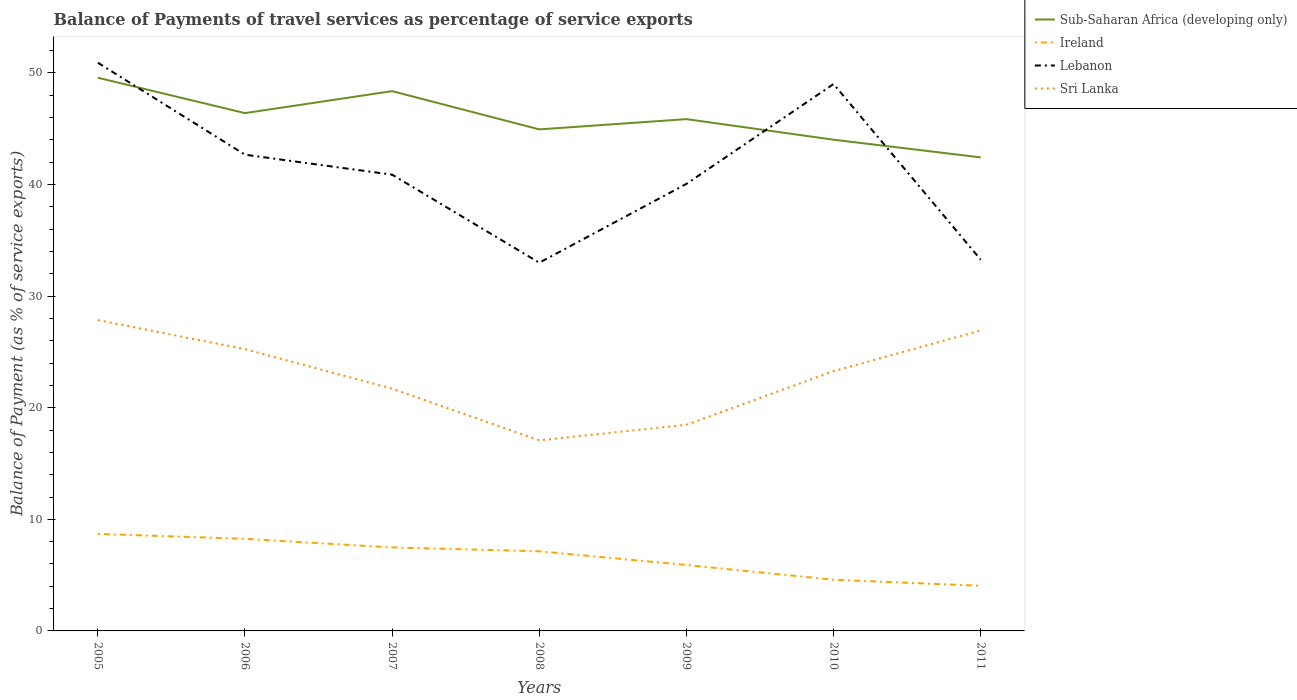Does the line corresponding to Sri Lanka intersect with the line corresponding to Sub-Saharan Africa (developing only)?
Offer a terse response. No. Across all years, what is the maximum balance of payments of travel services in Sub-Saharan Africa (developing only)?
Give a very brief answer. 42.43. In which year was the balance of payments of travel services in Sri Lanka maximum?
Ensure brevity in your answer.  2008. What is the total balance of payments of travel services in Lebanon in the graph?
Keep it short and to the point. 10.03. What is the difference between the highest and the second highest balance of payments of travel services in Ireland?
Offer a very short reply. 4.65. How many lines are there?
Give a very brief answer. 4. How many years are there in the graph?
Keep it short and to the point. 7. Are the values on the major ticks of Y-axis written in scientific E-notation?
Provide a short and direct response. No. Does the graph contain any zero values?
Provide a succinct answer. No. Does the graph contain grids?
Ensure brevity in your answer.  No. Where does the legend appear in the graph?
Give a very brief answer. Top right. How many legend labels are there?
Your response must be concise. 4. What is the title of the graph?
Your answer should be very brief. Balance of Payments of travel services as percentage of service exports. Does "Malta" appear as one of the legend labels in the graph?
Provide a short and direct response. No. What is the label or title of the Y-axis?
Provide a succinct answer. Balance of Payment (as % of service exports). What is the Balance of Payment (as % of service exports) of Sub-Saharan Africa (developing only) in 2005?
Provide a succinct answer. 49.57. What is the Balance of Payment (as % of service exports) in Ireland in 2005?
Your answer should be compact. 8.7. What is the Balance of Payment (as % of service exports) in Lebanon in 2005?
Your answer should be compact. 50.92. What is the Balance of Payment (as % of service exports) in Sri Lanka in 2005?
Your answer should be compact. 27.86. What is the Balance of Payment (as % of service exports) of Sub-Saharan Africa (developing only) in 2006?
Offer a terse response. 46.4. What is the Balance of Payment (as % of service exports) in Ireland in 2006?
Provide a short and direct response. 8.25. What is the Balance of Payment (as % of service exports) of Lebanon in 2006?
Make the answer very short. 42.68. What is the Balance of Payment (as % of service exports) of Sri Lanka in 2006?
Provide a succinct answer. 25.25. What is the Balance of Payment (as % of service exports) in Sub-Saharan Africa (developing only) in 2007?
Give a very brief answer. 48.37. What is the Balance of Payment (as % of service exports) in Ireland in 2007?
Your answer should be very brief. 7.48. What is the Balance of Payment (as % of service exports) of Lebanon in 2007?
Your answer should be very brief. 40.89. What is the Balance of Payment (as % of service exports) in Sri Lanka in 2007?
Ensure brevity in your answer.  21.71. What is the Balance of Payment (as % of service exports) in Sub-Saharan Africa (developing only) in 2008?
Ensure brevity in your answer.  44.94. What is the Balance of Payment (as % of service exports) of Ireland in 2008?
Ensure brevity in your answer.  7.14. What is the Balance of Payment (as % of service exports) of Lebanon in 2008?
Offer a very short reply. 33. What is the Balance of Payment (as % of service exports) of Sri Lanka in 2008?
Provide a short and direct response. 17.08. What is the Balance of Payment (as % of service exports) in Sub-Saharan Africa (developing only) in 2009?
Keep it short and to the point. 45.86. What is the Balance of Payment (as % of service exports) in Ireland in 2009?
Offer a very short reply. 5.91. What is the Balance of Payment (as % of service exports) in Lebanon in 2009?
Offer a terse response. 40.06. What is the Balance of Payment (as % of service exports) of Sri Lanka in 2009?
Offer a very short reply. 18.47. What is the Balance of Payment (as % of service exports) of Sub-Saharan Africa (developing only) in 2010?
Make the answer very short. 44.02. What is the Balance of Payment (as % of service exports) of Ireland in 2010?
Offer a terse response. 4.59. What is the Balance of Payment (as % of service exports) in Lebanon in 2010?
Your response must be concise. 49.01. What is the Balance of Payment (as % of service exports) in Sri Lanka in 2010?
Give a very brief answer. 23.28. What is the Balance of Payment (as % of service exports) in Sub-Saharan Africa (developing only) in 2011?
Make the answer very short. 42.43. What is the Balance of Payment (as % of service exports) of Ireland in 2011?
Offer a very short reply. 4.04. What is the Balance of Payment (as % of service exports) of Lebanon in 2011?
Give a very brief answer. 33.27. What is the Balance of Payment (as % of service exports) of Sri Lanka in 2011?
Offer a terse response. 26.92. Across all years, what is the maximum Balance of Payment (as % of service exports) in Sub-Saharan Africa (developing only)?
Provide a succinct answer. 49.57. Across all years, what is the maximum Balance of Payment (as % of service exports) in Ireland?
Keep it short and to the point. 8.7. Across all years, what is the maximum Balance of Payment (as % of service exports) of Lebanon?
Your answer should be compact. 50.92. Across all years, what is the maximum Balance of Payment (as % of service exports) of Sri Lanka?
Your response must be concise. 27.86. Across all years, what is the minimum Balance of Payment (as % of service exports) in Sub-Saharan Africa (developing only)?
Offer a very short reply. 42.43. Across all years, what is the minimum Balance of Payment (as % of service exports) in Ireland?
Give a very brief answer. 4.04. Across all years, what is the minimum Balance of Payment (as % of service exports) in Lebanon?
Keep it short and to the point. 33. Across all years, what is the minimum Balance of Payment (as % of service exports) in Sri Lanka?
Your response must be concise. 17.08. What is the total Balance of Payment (as % of service exports) in Sub-Saharan Africa (developing only) in the graph?
Offer a terse response. 321.6. What is the total Balance of Payment (as % of service exports) in Ireland in the graph?
Provide a succinct answer. 46.11. What is the total Balance of Payment (as % of service exports) in Lebanon in the graph?
Offer a very short reply. 289.81. What is the total Balance of Payment (as % of service exports) of Sri Lanka in the graph?
Keep it short and to the point. 160.57. What is the difference between the Balance of Payment (as % of service exports) of Sub-Saharan Africa (developing only) in 2005 and that in 2006?
Your answer should be very brief. 3.17. What is the difference between the Balance of Payment (as % of service exports) in Ireland in 2005 and that in 2006?
Offer a terse response. 0.45. What is the difference between the Balance of Payment (as % of service exports) in Lebanon in 2005 and that in 2006?
Your response must be concise. 8.24. What is the difference between the Balance of Payment (as % of service exports) of Sri Lanka in 2005 and that in 2006?
Keep it short and to the point. 2.61. What is the difference between the Balance of Payment (as % of service exports) of Sub-Saharan Africa (developing only) in 2005 and that in 2007?
Ensure brevity in your answer.  1.2. What is the difference between the Balance of Payment (as % of service exports) in Ireland in 2005 and that in 2007?
Your answer should be very brief. 1.22. What is the difference between the Balance of Payment (as % of service exports) of Lebanon in 2005 and that in 2007?
Your answer should be very brief. 10.03. What is the difference between the Balance of Payment (as % of service exports) in Sri Lanka in 2005 and that in 2007?
Give a very brief answer. 6.15. What is the difference between the Balance of Payment (as % of service exports) of Sub-Saharan Africa (developing only) in 2005 and that in 2008?
Offer a terse response. 4.63. What is the difference between the Balance of Payment (as % of service exports) in Ireland in 2005 and that in 2008?
Your answer should be compact. 1.56. What is the difference between the Balance of Payment (as % of service exports) of Lebanon in 2005 and that in 2008?
Your answer should be very brief. 17.92. What is the difference between the Balance of Payment (as % of service exports) in Sri Lanka in 2005 and that in 2008?
Provide a short and direct response. 10.78. What is the difference between the Balance of Payment (as % of service exports) in Sub-Saharan Africa (developing only) in 2005 and that in 2009?
Provide a succinct answer. 3.71. What is the difference between the Balance of Payment (as % of service exports) of Ireland in 2005 and that in 2009?
Your answer should be very brief. 2.79. What is the difference between the Balance of Payment (as % of service exports) of Lebanon in 2005 and that in 2009?
Offer a very short reply. 10.86. What is the difference between the Balance of Payment (as % of service exports) of Sri Lanka in 2005 and that in 2009?
Give a very brief answer. 9.38. What is the difference between the Balance of Payment (as % of service exports) of Sub-Saharan Africa (developing only) in 2005 and that in 2010?
Give a very brief answer. 5.55. What is the difference between the Balance of Payment (as % of service exports) of Ireland in 2005 and that in 2010?
Your response must be concise. 4.11. What is the difference between the Balance of Payment (as % of service exports) of Lebanon in 2005 and that in 2010?
Ensure brevity in your answer.  1.91. What is the difference between the Balance of Payment (as % of service exports) of Sri Lanka in 2005 and that in 2010?
Provide a short and direct response. 4.58. What is the difference between the Balance of Payment (as % of service exports) of Sub-Saharan Africa (developing only) in 2005 and that in 2011?
Offer a terse response. 7.14. What is the difference between the Balance of Payment (as % of service exports) of Ireland in 2005 and that in 2011?
Your answer should be compact. 4.65. What is the difference between the Balance of Payment (as % of service exports) of Lebanon in 2005 and that in 2011?
Keep it short and to the point. 17.65. What is the difference between the Balance of Payment (as % of service exports) of Sri Lanka in 2005 and that in 2011?
Offer a very short reply. 0.94. What is the difference between the Balance of Payment (as % of service exports) in Sub-Saharan Africa (developing only) in 2006 and that in 2007?
Offer a very short reply. -1.97. What is the difference between the Balance of Payment (as % of service exports) of Ireland in 2006 and that in 2007?
Offer a terse response. 0.77. What is the difference between the Balance of Payment (as % of service exports) in Lebanon in 2006 and that in 2007?
Your answer should be very brief. 1.79. What is the difference between the Balance of Payment (as % of service exports) in Sri Lanka in 2006 and that in 2007?
Provide a short and direct response. 3.54. What is the difference between the Balance of Payment (as % of service exports) of Sub-Saharan Africa (developing only) in 2006 and that in 2008?
Provide a succinct answer. 1.46. What is the difference between the Balance of Payment (as % of service exports) in Ireland in 2006 and that in 2008?
Offer a very short reply. 1.11. What is the difference between the Balance of Payment (as % of service exports) in Lebanon in 2006 and that in 2008?
Your answer should be very brief. 9.68. What is the difference between the Balance of Payment (as % of service exports) of Sri Lanka in 2006 and that in 2008?
Ensure brevity in your answer.  8.17. What is the difference between the Balance of Payment (as % of service exports) of Sub-Saharan Africa (developing only) in 2006 and that in 2009?
Your response must be concise. 0.54. What is the difference between the Balance of Payment (as % of service exports) in Ireland in 2006 and that in 2009?
Offer a terse response. 2.34. What is the difference between the Balance of Payment (as % of service exports) in Lebanon in 2006 and that in 2009?
Offer a terse response. 2.62. What is the difference between the Balance of Payment (as % of service exports) in Sri Lanka in 2006 and that in 2009?
Make the answer very short. 6.78. What is the difference between the Balance of Payment (as % of service exports) of Sub-Saharan Africa (developing only) in 2006 and that in 2010?
Your answer should be very brief. 2.38. What is the difference between the Balance of Payment (as % of service exports) of Ireland in 2006 and that in 2010?
Your answer should be compact. 3.67. What is the difference between the Balance of Payment (as % of service exports) in Lebanon in 2006 and that in 2010?
Your answer should be compact. -6.33. What is the difference between the Balance of Payment (as % of service exports) of Sri Lanka in 2006 and that in 2010?
Keep it short and to the point. 1.97. What is the difference between the Balance of Payment (as % of service exports) in Sub-Saharan Africa (developing only) in 2006 and that in 2011?
Offer a terse response. 3.97. What is the difference between the Balance of Payment (as % of service exports) in Ireland in 2006 and that in 2011?
Your response must be concise. 4.21. What is the difference between the Balance of Payment (as % of service exports) in Lebanon in 2006 and that in 2011?
Make the answer very short. 9.41. What is the difference between the Balance of Payment (as % of service exports) of Sri Lanka in 2006 and that in 2011?
Offer a terse response. -1.67. What is the difference between the Balance of Payment (as % of service exports) of Sub-Saharan Africa (developing only) in 2007 and that in 2008?
Offer a very short reply. 3.43. What is the difference between the Balance of Payment (as % of service exports) in Ireland in 2007 and that in 2008?
Ensure brevity in your answer.  0.35. What is the difference between the Balance of Payment (as % of service exports) in Lebanon in 2007 and that in 2008?
Ensure brevity in your answer.  7.89. What is the difference between the Balance of Payment (as % of service exports) in Sri Lanka in 2007 and that in 2008?
Keep it short and to the point. 4.63. What is the difference between the Balance of Payment (as % of service exports) of Sub-Saharan Africa (developing only) in 2007 and that in 2009?
Ensure brevity in your answer.  2.51. What is the difference between the Balance of Payment (as % of service exports) of Ireland in 2007 and that in 2009?
Ensure brevity in your answer.  1.57. What is the difference between the Balance of Payment (as % of service exports) of Lebanon in 2007 and that in 2009?
Keep it short and to the point. 0.83. What is the difference between the Balance of Payment (as % of service exports) of Sri Lanka in 2007 and that in 2009?
Your answer should be very brief. 3.23. What is the difference between the Balance of Payment (as % of service exports) in Sub-Saharan Africa (developing only) in 2007 and that in 2010?
Offer a terse response. 4.35. What is the difference between the Balance of Payment (as % of service exports) of Ireland in 2007 and that in 2010?
Your response must be concise. 2.9. What is the difference between the Balance of Payment (as % of service exports) of Lebanon in 2007 and that in 2010?
Your answer should be very brief. -8.12. What is the difference between the Balance of Payment (as % of service exports) of Sri Lanka in 2007 and that in 2010?
Your answer should be compact. -1.57. What is the difference between the Balance of Payment (as % of service exports) of Sub-Saharan Africa (developing only) in 2007 and that in 2011?
Provide a short and direct response. 5.94. What is the difference between the Balance of Payment (as % of service exports) in Ireland in 2007 and that in 2011?
Your answer should be very brief. 3.44. What is the difference between the Balance of Payment (as % of service exports) of Lebanon in 2007 and that in 2011?
Keep it short and to the point. 7.62. What is the difference between the Balance of Payment (as % of service exports) of Sri Lanka in 2007 and that in 2011?
Provide a succinct answer. -5.22. What is the difference between the Balance of Payment (as % of service exports) in Sub-Saharan Africa (developing only) in 2008 and that in 2009?
Offer a terse response. -0.92. What is the difference between the Balance of Payment (as % of service exports) of Ireland in 2008 and that in 2009?
Give a very brief answer. 1.23. What is the difference between the Balance of Payment (as % of service exports) of Lebanon in 2008 and that in 2009?
Make the answer very short. -7.06. What is the difference between the Balance of Payment (as % of service exports) in Sri Lanka in 2008 and that in 2009?
Your answer should be compact. -1.39. What is the difference between the Balance of Payment (as % of service exports) of Sub-Saharan Africa (developing only) in 2008 and that in 2010?
Ensure brevity in your answer.  0.92. What is the difference between the Balance of Payment (as % of service exports) in Ireland in 2008 and that in 2010?
Your answer should be compact. 2.55. What is the difference between the Balance of Payment (as % of service exports) of Lebanon in 2008 and that in 2010?
Provide a succinct answer. -16.01. What is the difference between the Balance of Payment (as % of service exports) of Sri Lanka in 2008 and that in 2010?
Offer a terse response. -6.2. What is the difference between the Balance of Payment (as % of service exports) in Sub-Saharan Africa (developing only) in 2008 and that in 2011?
Your response must be concise. 2.51. What is the difference between the Balance of Payment (as % of service exports) of Ireland in 2008 and that in 2011?
Keep it short and to the point. 3.09. What is the difference between the Balance of Payment (as % of service exports) in Lebanon in 2008 and that in 2011?
Keep it short and to the point. -0.27. What is the difference between the Balance of Payment (as % of service exports) in Sri Lanka in 2008 and that in 2011?
Keep it short and to the point. -9.84. What is the difference between the Balance of Payment (as % of service exports) of Sub-Saharan Africa (developing only) in 2009 and that in 2010?
Your answer should be very brief. 1.84. What is the difference between the Balance of Payment (as % of service exports) in Ireland in 2009 and that in 2010?
Give a very brief answer. 1.32. What is the difference between the Balance of Payment (as % of service exports) of Lebanon in 2009 and that in 2010?
Give a very brief answer. -8.95. What is the difference between the Balance of Payment (as % of service exports) in Sri Lanka in 2009 and that in 2010?
Provide a succinct answer. -4.8. What is the difference between the Balance of Payment (as % of service exports) of Sub-Saharan Africa (developing only) in 2009 and that in 2011?
Provide a short and direct response. 3.43. What is the difference between the Balance of Payment (as % of service exports) in Ireland in 2009 and that in 2011?
Offer a terse response. 1.86. What is the difference between the Balance of Payment (as % of service exports) of Lebanon in 2009 and that in 2011?
Your answer should be compact. 6.79. What is the difference between the Balance of Payment (as % of service exports) of Sri Lanka in 2009 and that in 2011?
Your response must be concise. -8.45. What is the difference between the Balance of Payment (as % of service exports) in Sub-Saharan Africa (developing only) in 2010 and that in 2011?
Provide a short and direct response. 1.59. What is the difference between the Balance of Payment (as % of service exports) of Ireland in 2010 and that in 2011?
Provide a succinct answer. 0.54. What is the difference between the Balance of Payment (as % of service exports) in Lebanon in 2010 and that in 2011?
Provide a short and direct response. 15.74. What is the difference between the Balance of Payment (as % of service exports) of Sri Lanka in 2010 and that in 2011?
Provide a succinct answer. -3.65. What is the difference between the Balance of Payment (as % of service exports) in Sub-Saharan Africa (developing only) in 2005 and the Balance of Payment (as % of service exports) in Ireland in 2006?
Your answer should be very brief. 41.32. What is the difference between the Balance of Payment (as % of service exports) in Sub-Saharan Africa (developing only) in 2005 and the Balance of Payment (as % of service exports) in Lebanon in 2006?
Make the answer very short. 6.9. What is the difference between the Balance of Payment (as % of service exports) in Sub-Saharan Africa (developing only) in 2005 and the Balance of Payment (as % of service exports) in Sri Lanka in 2006?
Provide a succinct answer. 24.32. What is the difference between the Balance of Payment (as % of service exports) of Ireland in 2005 and the Balance of Payment (as % of service exports) of Lebanon in 2006?
Provide a short and direct response. -33.98. What is the difference between the Balance of Payment (as % of service exports) in Ireland in 2005 and the Balance of Payment (as % of service exports) in Sri Lanka in 2006?
Offer a very short reply. -16.55. What is the difference between the Balance of Payment (as % of service exports) of Lebanon in 2005 and the Balance of Payment (as % of service exports) of Sri Lanka in 2006?
Offer a very short reply. 25.67. What is the difference between the Balance of Payment (as % of service exports) in Sub-Saharan Africa (developing only) in 2005 and the Balance of Payment (as % of service exports) in Ireland in 2007?
Give a very brief answer. 42.09. What is the difference between the Balance of Payment (as % of service exports) in Sub-Saharan Africa (developing only) in 2005 and the Balance of Payment (as % of service exports) in Lebanon in 2007?
Offer a very short reply. 8.69. What is the difference between the Balance of Payment (as % of service exports) in Sub-Saharan Africa (developing only) in 2005 and the Balance of Payment (as % of service exports) in Sri Lanka in 2007?
Provide a short and direct response. 27.86. What is the difference between the Balance of Payment (as % of service exports) in Ireland in 2005 and the Balance of Payment (as % of service exports) in Lebanon in 2007?
Keep it short and to the point. -32.19. What is the difference between the Balance of Payment (as % of service exports) in Ireland in 2005 and the Balance of Payment (as % of service exports) in Sri Lanka in 2007?
Offer a terse response. -13.01. What is the difference between the Balance of Payment (as % of service exports) of Lebanon in 2005 and the Balance of Payment (as % of service exports) of Sri Lanka in 2007?
Provide a succinct answer. 29.21. What is the difference between the Balance of Payment (as % of service exports) of Sub-Saharan Africa (developing only) in 2005 and the Balance of Payment (as % of service exports) of Ireland in 2008?
Give a very brief answer. 42.43. What is the difference between the Balance of Payment (as % of service exports) in Sub-Saharan Africa (developing only) in 2005 and the Balance of Payment (as % of service exports) in Lebanon in 2008?
Your response must be concise. 16.58. What is the difference between the Balance of Payment (as % of service exports) in Sub-Saharan Africa (developing only) in 2005 and the Balance of Payment (as % of service exports) in Sri Lanka in 2008?
Provide a succinct answer. 32.49. What is the difference between the Balance of Payment (as % of service exports) in Ireland in 2005 and the Balance of Payment (as % of service exports) in Lebanon in 2008?
Make the answer very short. -24.3. What is the difference between the Balance of Payment (as % of service exports) in Ireland in 2005 and the Balance of Payment (as % of service exports) in Sri Lanka in 2008?
Give a very brief answer. -8.38. What is the difference between the Balance of Payment (as % of service exports) in Lebanon in 2005 and the Balance of Payment (as % of service exports) in Sri Lanka in 2008?
Your response must be concise. 33.84. What is the difference between the Balance of Payment (as % of service exports) in Sub-Saharan Africa (developing only) in 2005 and the Balance of Payment (as % of service exports) in Ireland in 2009?
Make the answer very short. 43.66. What is the difference between the Balance of Payment (as % of service exports) of Sub-Saharan Africa (developing only) in 2005 and the Balance of Payment (as % of service exports) of Lebanon in 2009?
Your response must be concise. 9.51. What is the difference between the Balance of Payment (as % of service exports) in Sub-Saharan Africa (developing only) in 2005 and the Balance of Payment (as % of service exports) in Sri Lanka in 2009?
Keep it short and to the point. 31.1. What is the difference between the Balance of Payment (as % of service exports) in Ireland in 2005 and the Balance of Payment (as % of service exports) in Lebanon in 2009?
Keep it short and to the point. -31.36. What is the difference between the Balance of Payment (as % of service exports) in Ireland in 2005 and the Balance of Payment (as % of service exports) in Sri Lanka in 2009?
Offer a very short reply. -9.78. What is the difference between the Balance of Payment (as % of service exports) of Lebanon in 2005 and the Balance of Payment (as % of service exports) of Sri Lanka in 2009?
Give a very brief answer. 32.44. What is the difference between the Balance of Payment (as % of service exports) of Sub-Saharan Africa (developing only) in 2005 and the Balance of Payment (as % of service exports) of Ireland in 2010?
Your answer should be compact. 44.99. What is the difference between the Balance of Payment (as % of service exports) of Sub-Saharan Africa (developing only) in 2005 and the Balance of Payment (as % of service exports) of Lebanon in 2010?
Ensure brevity in your answer.  0.57. What is the difference between the Balance of Payment (as % of service exports) in Sub-Saharan Africa (developing only) in 2005 and the Balance of Payment (as % of service exports) in Sri Lanka in 2010?
Your answer should be compact. 26.29. What is the difference between the Balance of Payment (as % of service exports) of Ireland in 2005 and the Balance of Payment (as % of service exports) of Lebanon in 2010?
Your response must be concise. -40.31. What is the difference between the Balance of Payment (as % of service exports) of Ireland in 2005 and the Balance of Payment (as % of service exports) of Sri Lanka in 2010?
Offer a very short reply. -14.58. What is the difference between the Balance of Payment (as % of service exports) in Lebanon in 2005 and the Balance of Payment (as % of service exports) in Sri Lanka in 2010?
Your answer should be very brief. 27.64. What is the difference between the Balance of Payment (as % of service exports) in Sub-Saharan Africa (developing only) in 2005 and the Balance of Payment (as % of service exports) in Ireland in 2011?
Make the answer very short. 45.53. What is the difference between the Balance of Payment (as % of service exports) in Sub-Saharan Africa (developing only) in 2005 and the Balance of Payment (as % of service exports) in Lebanon in 2011?
Offer a terse response. 16.3. What is the difference between the Balance of Payment (as % of service exports) of Sub-Saharan Africa (developing only) in 2005 and the Balance of Payment (as % of service exports) of Sri Lanka in 2011?
Give a very brief answer. 22.65. What is the difference between the Balance of Payment (as % of service exports) in Ireland in 2005 and the Balance of Payment (as % of service exports) in Lebanon in 2011?
Your answer should be very brief. -24.57. What is the difference between the Balance of Payment (as % of service exports) in Ireland in 2005 and the Balance of Payment (as % of service exports) in Sri Lanka in 2011?
Provide a short and direct response. -18.23. What is the difference between the Balance of Payment (as % of service exports) of Lebanon in 2005 and the Balance of Payment (as % of service exports) of Sri Lanka in 2011?
Your answer should be compact. 23.99. What is the difference between the Balance of Payment (as % of service exports) in Sub-Saharan Africa (developing only) in 2006 and the Balance of Payment (as % of service exports) in Ireland in 2007?
Keep it short and to the point. 38.92. What is the difference between the Balance of Payment (as % of service exports) of Sub-Saharan Africa (developing only) in 2006 and the Balance of Payment (as % of service exports) of Lebanon in 2007?
Make the answer very short. 5.52. What is the difference between the Balance of Payment (as % of service exports) of Sub-Saharan Africa (developing only) in 2006 and the Balance of Payment (as % of service exports) of Sri Lanka in 2007?
Your answer should be very brief. 24.7. What is the difference between the Balance of Payment (as % of service exports) of Ireland in 2006 and the Balance of Payment (as % of service exports) of Lebanon in 2007?
Give a very brief answer. -32.63. What is the difference between the Balance of Payment (as % of service exports) in Ireland in 2006 and the Balance of Payment (as % of service exports) in Sri Lanka in 2007?
Ensure brevity in your answer.  -13.46. What is the difference between the Balance of Payment (as % of service exports) in Lebanon in 2006 and the Balance of Payment (as % of service exports) in Sri Lanka in 2007?
Provide a succinct answer. 20.97. What is the difference between the Balance of Payment (as % of service exports) of Sub-Saharan Africa (developing only) in 2006 and the Balance of Payment (as % of service exports) of Ireland in 2008?
Ensure brevity in your answer.  39.27. What is the difference between the Balance of Payment (as % of service exports) of Sub-Saharan Africa (developing only) in 2006 and the Balance of Payment (as % of service exports) of Lebanon in 2008?
Your answer should be compact. 13.41. What is the difference between the Balance of Payment (as % of service exports) in Sub-Saharan Africa (developing only) in 2006 and the Balance of Payment (as % of service exports) in Sri Lanka in 2008?
Provide a succinct answer. 29.32. What is the difference between the Balance of Payment (as % of service exports) in Ireland in 2006 and the Balance of Payment (as % of service exports) in Lebanon in 2008?
Ensure brevity in your answer.  -24.74. What is the difference between the Balance of Payment (as % of service exports) of Ireland in 2006 and the Balance of Payment (as % of service exports) of Sri Lanka in 2008?
Your response must be concise. -8.83. What is the difference between the Balance of Payment (as % of service exports) in Lebanon in 2006 and the Balance of Payment (as % of service exports) in Sri Lanka in 2008?
Your answer should be very brief. 25.6. What is the difference between the Balance of Payment (as % of service exports) in Sub-Saharan Africa (developing only) in 2006 and the Balance of Payment (as % of service exports) in Ireland in 2009?
Your response must be concise. 40.49. What is the difference between the Balance of Payment (as % of service exports) in Sub-Saharan Africa (developing only) in 2006 and the Balance of Payment (as % of service exports) in Lebanon in 2009?
Keep it short and to the point. 6.34. What is the difference between the Balance of Payment (as % of service exports) of Sub-Saharan Africa (developing only) in 2006 and the Balance of Payment (as % of service exports) of Sri Lanka in 2009?
Offer a very short reply. 27.93. What is the difference between the Balance of Payment (as % of service exports) of Ireland in 2006 and the Balance of Payment (as % of service exports) of Lebanon in 2009?
Offer a very short reply. -31.81. What is the difference between the Balance of Payment (as % of service exports) of Ireland in 2006 and the Balance of Payment (as % of service exports) of Sri Lanka in 2009?
Provide a short and direct response. -10.22. What is the difference between the Balance of Payment (as % of service exports) in Lebanon in 2006 and the Balance of Payment (as % of service exports) in Sri Lanka in 2009?
Your response must be concise. 24.2. What is the difference between the Balance of Payment (as % of service exports) in Sub-Saharan Africa (developing only) in 2006 and the Balance of Payment (as % of service exports) in Ireland in 2010?
Provide a succinct answer. 41.82. What is the difference between the Balance of Payment (as % of service exports) of Sub-Saharan Africa (developing only) in 2006 and the Balance of Payment (as % of service exports) of Lebanon in 2010?
Offer a terse response. -2.6. What is the difference between the Balance of Payment (as % of service exports) of Sub-Saharan Africa (developing only) in 2006 and the Balance of Payment (as % of service exports) of Sri Lanka in 2010?
Make the answer very short. 23.12. What is the difference between the Balance of Payment (as % of service exports) of Ireland in 2006 and the Balance of Payment (as % of service exports) of Lebanon in 2010?
Keep it short and to the point. -40.76. What is the difference between the Balance of Payment (as % of service exports) of Ireland in 2006 and the Balance of Payment (as % of service exports) of Sri Lanka in 2010?
Give a very brief answer. -15.03. What is the difference between the Balance of Payment (as % of service exports) of Lebanon in 2006 and the Balance of Payment (as % of service exports) of Sri Lanka in 2010?
Keep it short and to the point. 19.4. What is the difference between the Balance of Payment (as % of service exports) in Sub-Saharan Africa (developing only) in 2006 and the Balance of Payment (as % of service exports) in Ireland in 2011?
Provide a succinct answer. 42.36. What is the difference between the Balance of Payment (as % of service exports) in Sub-Saharan Africa (developing only) in 2006 and the Balance of Payment (as % of service exports) in Lebanon in 2011?
Provide a succinct answer. 13.13. What is the difference between the Balance of Payment (as % of service exports) of Sub-Saharan Africa (developing only) in 2006 and the Balance of Payment (as % of service exports) of Sri Lanka in 2011?
Provide a short and direct response. 19.48. What is the difference between the Balance of Payment (as % of service exports) of Ireland in 2006 and the Balance of Payment (as % of service exports) of Lebanon in 2011?
Your response must be concise. -25.02. What is the difference between the Balance of Payment (as % of service exports) in Ireland in 2006 and the Balance of Payment (as % of service exports) in Sri Lanka in 2011?
Ensure brevity in your answer.  -18.67. What is the difference between the Balance of Payment (as % of service exports) in Lebanon in 2006 and the Balance of Payment (as % of service exports) in Sri Lanka in 2011?
Give a very brief answer. 15.75. What is the difference between the Balance of Payment (as % of service exports) in Sub-Saharan Africa (developing only) in 2007 and the Balance of Payment (as % of service exports) in Ireland in 2008?
Ensure brevity in your answer.  41.23. What is the difference between the Balance of Payment (as % of service exports) of Sub-Saharan Africa (developing only) in 2007 and the Balance of Payment (as % of service exports) of Lebanon in 2008?
Offer a terse response. 15.38. What is the difference between the Balance of Payment (as % of service exports) in Sub-Saharan Africa (developing only) in 2007 and the Balance of Payment (as % of service exports) in Sri Lanka in 2008?
Offer a very short reply. 31.29. What is the difference between the Balance of Payment (as % of service exports) in Ireland in 2007 and the Balance of Payment (as % of service exports) in Lebanon in 2008?
Make the answer very short. -25.51. What is the difference between the Balance of Payment (as % of service exports) of Ireland in 2007 and the Balance of Payment (as % of service exports) of Sri Lanka in 2008?
Offer a very short reply. -9.6. What is the difference between the Balance of Payment (as % of service exports) of Lebanon in 2007 and the Balance of Payment (as % of service exports) of Sri Lanka in 2008?
Your answer should be compact. 23.81. What is the difference between the Balance of Payment (as % of service exports) of Sub-Saharan Africa (developing only) in 2007 and the Balance of Payment (as % of service exports) of Ireland in 2009?
Offer a very short reply. 42.46. What is the difference between the Balance of Payment (as % of service exports) of Sub-Saharan Africa (developing only) in 2007 and the Balance of Payment (as % of service exports) of Lebanon in 2009?
Your answer should be very brief. 8.31. What is the difference between the Balance of Payment (as % of service exports) in Sub-Saharan Africa (developing only) in 2007 and the Balance of Payment (as % of service exports) in Sri Lanka in 2009?
Provide a short and direct response. 29.9. What is the difference between the Balance of Payment (as % of service exports) in Ireland in 2007 and the Balance of Payment (as % of service exports) in Lebanon in 2009?
Your answer should be compact. -32.58. What is the difference between the Balance of Payment (as % of service exports) in Ireland in 2007 and the Balance of Payment (as % of service exports) in Sri Lanka in 2009?
Give a very brief answer. -10.99. What is the difference between the Balance of Payment (as % of service exports) in Lebanon in 2007 and the Balance of Payment (as % of service exports) in Sri Lanka in 2009?
Keep it short and to the point. 22.41. What is the difference between the Balance of Payment (as % of service exports) in Sub-Saharan Africa (developing only) in 2007 and the Balance of Payment (as % of service exports) in Ireland in 2010?
Provide a short and direct response. 43.79. What is the difference between the Balance of Payment (as % of service exports) of Sub-Saharan Africa (developing only) in 2007 and the Balance of Payment (as % of service exports) of Lebanon in 2010?
Offer a terse response. -0.64. What is the difference between the Balance of Payment (as % of service exports) in Sub-Saharan Africa (developing only) in 2007 and the Balance of Payment (as % of service exports) in Sri Lanka in 2010?
Ensure brevity in your answer.  25.09. What is the difference between the Balance of Payment (as % of service exports) of Ireland in 2007 and the Balance of Payment (as % of service exports) of Lebanon in 2010?
Your answer should be compact. -41.52. What is the difference between the Balance of Payment (as % of service exports) in Ireland in 2007 and the Balance of Payment (as % of service exports) in Sri Lanka in 2010?
Provide a short and direct response. -15.8. What is the difference between the Balance of Payment (as % of service exports) of Lebanon in 2007 and the Balance of Payment (as % of service exports) of Sri Lanka in 2010?
Give a very brief answer. 17.61. What is the difference between the Balance of Payment (as % of service exports) of Sub-Saharan Africa (developing only) in 2007 and the Balance of Payment (as % of service exports) of Ireland in 2011?
Your answer should be compact. 44.33. What is the difference between the Balance of Payment (as % of service exports) in Sub-Saharan Africa (developing only) in 2007 and the Balance of Payment (as % of service exports) in Lebanon in 2011?
Your answer should be very brief. 15.1. What is the difference between the Balance of Payment (as % of service exports) of Sub-Saharan Africa (developing only) in 2007 and the Balance of Payment (as % of service exports) of Sri Lanka in 2011?
Offer a very short reply. 21.45. What is the difference between the Balance of Payment (as % of service exports) of Ireland in 2007 and the Balance of Payment (as % of service exports) of Lebanon in 2011?
Ensure brevity in your answer.  -25.79. What is the difference between the Balance of Payment (as % of service exports) of Ireland in 2007 and the Balance of Payment (as % of service exports) of Sri Lanka in 2011?
Make the answer very short. -19.44. What is the difference between the Balance of Payment (as % of service exports) in Lebanon in 2007 and the Balance of Payment (as % of service exports) in Sri Lanka in 2011?
Your answer should be compact. 13.96. What is the difference between the Balance of Payment (as % of service exports) in Sub-Saharan Africa (developing only) in 2008 and the Balance of Payment (as % of service exports) in Ireland in 2009?
Your answer should be very brief. 39.04. What is the difference between the Balance of Payment (as % of service exports) in Sub-Saharan Africa (developing only) in 2008 and the Balance of Payment (as % of service exports) in Lebanon in 2009?
Make the answer very short. 4.88. What is the difference between the Balance of Payment (as % of service exports) of Sub-Saharan Africa (developing only) in 2008 and the Balance of Payment (as % of service exports) of Sri Lanka in 2009?
Provide a short and direct response. 26.47. What is the difference between the Balance of Payment (as % of service exports) of Ireland in 2008 and the Balance of Payment (as % of service exports) of Lebanon in 2009?
Your answer should be very brief. -32.92. What is the difference between the Balance of Payment (as % of service exports) in Ireland in 2008 and the Balance of Payment (as % of service exports) in Sri Lanka in 2009?
Offer a terse response. -11.34. What is the difference between the Balance of Payment (as % of service exports) in Lebanon in 2008 and the Balance of Payment (as % of service exports) in Sri Lanka in 2009?
Make the answer very short. 14.52. What is the difference between the Balance of Payment (as % of service exports) in Sub-Saharan Africa (developing only) in 2008 and the Balance of Payment (as % of service exports) in Ireland in 2010?
Provide a short and direct response. 40.36. What is the difference between the Balance of Payment (as % of service exports) in Sub-Saharan Africa (developing only) in 2008 and the Balance of Payment (as % of service exports) in Lebanon in 2010?
Offer a very short reply. -4.06. What is the difference between the Balance of Payment (as % of service exports) of Sub-Saharan Africa (developing only) in 2008 and the Balance of Payment (as % of service exports) of Sri Lanka in 2010?
Make the answer very short. 21.67. What is the difference between the Balance of Payment (as % of service exports) in Ireland in 2008 and the Balance of Payment (as % of service exports) in Lebanon in 2010?
Ensure brevity in your answer.  -41.87. What is the difference between the Balance of Payment (as % of service exports) in Ireland in 2008 and the Balance of Payment (as % of service exports) in Sri Lanka in 2010?
Offer a very short reply. -16.14. What is the difference between the Balance of Payment (as % of service exports) in Lebanon in 2008 and the Balance of Payment (as % of service exports) in Sri Lanka in 2010?
Your answer should be very brief. 9.72. What is the difference between the Balance of Payment (as % of service exports) of Sub-Saharan Africa (developing only) in 2008 and the Balance of Payment (as % of service exports) of Ireland in 2011?
Give a very brief answer. 40.9. What is the difference between the Balance of Payment (as % of service exports) in Sub-Saharan Africa (developing only) in 2008 and the Balance of Payment (as % of service exports) in Lebanon in 2011?
Offer a terse response. 11.68. What is the difference between the Balance of Payment (as % of service exports) of Sub-Saharan Africa (developing only) in 2008 and the Balance of Payment (as % of service exports) of Sri Lanka in 2011?
Keep it short and to the point. 18.02. What is the difference between the Balance of Payment (as % of service exports) of Ireland in 2008 and the Balance of Payment (as % of service exports) of Lebanon in 2011?
Keep it short and to the point. -26.13. What is the difference between the Balance of Payment (as % of service exports) in Ireland in 2008 and the Balance of Payment (as % of service exports) in Sri Lanka in 2011?
Your response must be concise. -19.79. What is the difference between the Balance of Payment (as % of service exports) in Lebanon in 2008 and the Balance of Payment (as % of service exports) in Sri Lanka in 2011?
Keep it short and to the point. 6.07. What is the difference between the Balance of Payment (as % of service exports) of Sub-Saharan Africa (developing only) in 2009 and the Balance of Payment (as % of service exports) of Ireland in 2010?
Make the answer very short. 41.28. What is the difference between the Balance of Payment (as % of service exports) in Sub-Saharan Africa (developing only) in 2009 and the Balance of Payment (as % of service exports) in Lebanon in 2010?
Offer a very short reply. -3.14. What is the difference between the Balance of Payment (as % of service exports) in Sub-Saharan Africa (developing only) in 2009 and the Balance of Payment (as % of service exports) in Sri Lanka in 2010?
Make the answer very short. 22.58. What is the difference between the Balance of Payment (as % of service exports) of Ireland in 2009 and the Balance of Payment (as % of service exports) of Lebanon in 2010?
Ensure brevity in your answer.  -43.1. What is the difference between the Balance of Payment (as % of service exports) in Ireland in 2009 and the Balance of Payment (as % of service exports) in Sri Lanka in 2010?
Keep it short and to the point. -17.37. What is the difference between the Balance of Payment (as % of service exports) in Lebanon in 2009 and the Balance of Payment (as % of service exports) in Sri Lanka in 2010?
Your answer should be very brief. 16.78. What is the difference between the Balance of Payment (as % of service exports) in Sub-Saharan Africa (developing only) in 2009 and the Balance of Payment (as % of service exports) in Ireland in 2011?
Provide a succinct answer. 41.82. What is the difference between the Balance of Payment (as % of service exports) of Sub-Saharan Africa (developing only) in 2009 and the Balance of Payment (as % of service exports) of Lebanon in 2011?
Your answer should be compact. 12.59. What is the difference between the Balance of Payment (as % of service exports) in Sub-Saharan Africa (developing only) in 2009 and the Balance of Payment (as % of service exports) in Sri Lanka in 2011?
Provide a short and direct response. 18.94. What is the difference between the Balance of Payment (as % of service exports) in Ireland in 2009 and the Balance of Payment (as % of service exports) in Lebanon in 2011?
Keep it short and to the point. -27.36. What is the difference between the Balance of Payment (as % of service exports) in Ireland in 2009 and the Balance of Payment (as % of service exports) in Sri Lanka in 2011?
Your answer should be very brief. -21.02. What is the difference between the Balance of Payment (as % of service exports) in Lebanon in 2009 and the Balance of Payment (as % of service exports) in Sri Lanka in 2011?
Ensure brevity in your answer.  13.14. What is the difference between the Balance of Payment (as % of service exports) of Sub-Saharan Africa (developing only) in 2010 and the Balance of Payment (as % of service exports) of Ireland in 2011?
Give a very brief answer. 39.97. What is the difference between the Balance of Payment (as % of service exports) in Sub-Saharan Africa (developing only) in 2010 and the Balance of Payment (as % of service exports) in Lebanon in 2011?
Provide a succinct answer. 10.75. What is the difference between the Balance of Payment (as % of service exports) in Sub-Saharan Africa (developing only) in 2010 and the Balance of Payment (as % of service exports) in Sri Lanka in 2011?
Offer a terse response. 17.1. What is the difference between the Balance of Payment (as % of service exports) in Ireland in 2010 and the Balance of Payment (as % of service exports) in Lebanon in 2011?
Offer a very short reply. -28.68. What is the difference between the Balance of Payment (as % of service exports) in Ireland in 2010 and the Balance of Payment (as % of service exports) in Sri Lanka in 2011?
Keep it short and to the point. -22.34. What is the difference between the Balance of Payment (as % of service exports) of Lebanon in 2010 and the Balance of Payment (as % of service exports) of Sri Lanka in 2011?
Provide a short and direct response. 22.08. What is the average Balance of Payment (as % of service exports) in Sub-Saharan Africa (developing only) per year?
Offer a very short reply. 45.94. What is the average Balance of Payment (as % of service exports) in Ireland per year?
Provide a short and direct response. 6.59. What is the average Balance of Payment (as % of service exports) in Lebanon per year?
Offer a terse response. 41.4. What is the average Balance of Payment (as % of service exports) of Sri Lanka per year?
Keep it short and to the point. 22.94. In the year 2005, what is the difference between the Balance of Payment (as % of service exports) in Sub-Saharan Africa (developing only) and Balance of Payment (as % of service exports) in Ireland?
Your response must be concise. 40.87. In the year 2005, what is the difference between the Balance of Payment (as % of service exports) in Sub-Saharan Africa (developing only) and Balance of Payment (as % of service exports) in Lebanon?
Offer a very short reply. -1.35. In the year 2005, what is the difference between the Balance of Payment (as % of service exports) in Sub-Saharan Africa (developing only) and Balance of Payment (as % of service exports) in Sri Lanka?
Make the answer very short. 21.71. In the year 2005, what is the difference between the Balance of Payment (as % of service exports) in Ireland and Balance of Payment (as % of service exports) in Lebanon?
Offer a very short reply. -42.22. In the year 2005, what is the difference between the Balance of Payment (as % of service exports) in Ireland and Balance of Payment (as % of service exports) in Sri Lanka?
Your answer should be compact. -19.16. In the year 2005, what is the difference between the Balance of Payment (as % of service exports) in Lebanon and Balance of Payment (as % of service exports) in Sri Lanka?
Keep it short and to the point. 23.06. In the year 2006, what is the difference between the Balance of Payment (as % of service exports) of Sub-Saharan Africa (developing only) and Balance of Payment (as % of service exports) of Ireland?
Make the answer very short. 38.15. In the year 2006, what is the difference between the Balance of Payment (as % of service exports) in Sub-Saharan Africa (developing only) and Balance of Payment (as % of service exports) in Lebanon?
Ensure brevity in your answer.  3.73. In the year 2006, what is the difference between the Balance of Payment (as % of service exports) in Sub-Saharan Africa (developing only) and Balance of Payment (as % of service exports) in Sri Lanka?
Offer a terse response. 21.15. In the year 2006, what is the difference between the Balance of Payment (as % of service exports) in Ireland and Balance of Payment (as % of service exports) in Lebanon?
Your answer should be very brief. -34.42. In the year 2006, what is the difference between the Balance of Payment (as % of service exports) of Ireland and Balance of Payment (as % of service exports) of Sri Lanka?
Give a very brief answer. -17. In the year 2006, what is the difference between the Balance of Payment (as % of service exports) in Lebanon and Balance of Payment (as % of service exports) in Sri Lanka?
Ensure brevity in your answer.  17.42. In the year 2007, what is the difference between the Balance of Payment (as % of service exports) in Sub-Saharan Africa (developing only) and Balance of Payment (as % of service exports) in Ireland?
Offer a very short reply. 40.89. In the year 2007, what is the difference between the Balance of Payment (as % of service exports) of Sub-Saharan Africa (developing only) and Balance of Payment (as % of service exports) of Lebanon?
Your answer should be compact. 7.49. In the year 2007, what is the difference between the Balance of Payment (as % of service exports) in Sub-Saharan Africa (developing only) and Balance of Payment (as % of service exports) in Sri Lanka?
Offer a very short reply. 26.66. In the year 2007, what is the difference between the Balance of Payment (as % of service exports) of Ireland and Balance of Payment (as % of service exports) of Lebanon?
Keep it short and to the point. -33.4. In the year 2007, what is the difference between the Balance of Payment (as % of service exports) in Ireland and Balance of Payment (as % of service exports) in Sri Lanka?
Your answer should be compact. -14.22. In the year 2007, what is the difference between the Balance of Payment (as % of service exports) in Lebanon and Balance of Payment (as % of service exports) in Sri Lanka?
Offer a very short reply. 19.18. In the year 2008, what is the difference between the Balance of Payment (as % of service exports) of Sub-Saharan Africa (developing only) and Balance of Payment (as % of service exports) of Ireland?
Offer a terse response. 37.81. In the year 2008, what is the difference between the Balance of Payment (as % of service exports) of Sub-Saharan Africa (developing only) and Balance of Payment (as % of service exports) of Lebanon?
Keep it short and to the point. 11.95. In the year 2008, what is the difference between the Balance of Payment (as % of service exports) in Sub-Saharan Africa (developing only) and Balance of Payment (as % of service exports) in Sri Lanka?
Make the answer very short. 27.86. In the year 2008, what is the difference between the Balance of Payment (as % of service exports) in Ireland and Balance of Payment (as % of service exports) in Lebanon?
Give a very brief answer. -25.86. In the year 2008, what is the difference between the Balance of Payment (as % of service exports) in Ireland and Balance of Payment (as % of service exports) in Sri Lanka?
Your response must be concise. -9.94. In the year 2008, what is the difference between the Balance of Payment (as % of service exports) of Lebanon and Balance of Payment (as % of service exports) of Sri Lanka?
Your answer should be compact. 15.92. In the year 2009, what is the difference between the Balance of Payment (as % of service exports) in Sub-Saharan Africa (developing only) and Balance of Payment (as % of service exports) in Ireland?
Provide a succinct answer. 39.95. In the year 2009, what is the difference between the Balance of Payment (as % of service exports) in Sub-Saharan Africa (developing only) and Balance of Payment (as % of service exports) in Lebanon?
Keep it short and to the point. 5.8. In the year 2009, what is the difference between the Balance of Payment (as % of service exports) of Sub-Saharan Africa (developing only) and Balance of Payment (as % of service exports) of Sri Lanka?
Ensure brevity in your answer.  27.39. In the year 2009, what is the difference between the Balance of Payment (as % of service exports) of Ireland and Balance of Payment (as % of service exports) of Lebanon?
Your response must be concise. -34.15. In the year 2009, what is the difference between the Balance of Payment (as % of service exports) of Ireland and Balance of Payment (as % of service exports) of Sri Lanka?
Offer a terse response. -12.57. In the year 2009, what is the difference between the Balance of Payment (as % of service exports) in Lebanon and Balance of Payment (as % of service exports) in Sri Lanka?
Offer a terse response. 21.59. In the year 2010, what is the difference between the Balance of Payment (as % of service exports) of Sub-Saharan Africa (developing only) and Balance of Payment (as % of service exports) of Ireland?
Make the answer very short. 39.43. In the year 2010, what is the difference between the Balance of Payment (as % of service exports) in Sub-Saharan Africa (developing only) and Balance of Payment (as % of service exports) in Lebanon?
Make the answer very short. -4.99. In the year 2010, what is the difference between the Balance of Payment (as % of service exports) of Sub-Saharan Africa (developing only) and Balance of Payment (as % of service exports) of Sri Lanka?
Make the answer very short. 20.74. In the year 2010, what is the difference between the Balance of Payment (as % of service exports) in Ireland and Balance of Payment (as % of service exports) in Lebanon?
Offer a very short reply. -44.42. In the year 2010, what is the difference between the Balance of Payment (as % of service exports) in Ireland and Balance of Payment (as % of service exports) in Sri Lanka?
Provide a short and direct response. -18.69. In the year 2010, what is the difference between the Balance of Payment (as % of service exports) in Lebanon and Balance of Payment (as % of service exports) in Sri Lanka?
Offer a very short reply. 25.73. In the year 2011, what is the difference between the Balance of Payment (as % of service exports) in Sub-Saharan Africa (developing only) and Balance of Payment (as % of service exports) in Ireland?
Your response must be concise. 38.39. In the year 2011, what is the difference between the Balance of Payment (as % of service exports) in Sub-Saharan Africa (developing only) and Balance of Payment (as % of service exports) in Lebanon?
Make the answer very short. 9.16. In the year 2011, what is the difference between the Balance of Payment (as % of service exports) of Sub-Saharan Africa (developing only) and Balance of Payment (as % of service exports) of Sri Lanka?
Make the answer very short. 15.51. In the year 2011, what is the difference between the Balance of Payment (as % of service exports) in Ireland and Balance of Payment (as % of service exports) in Lebanon?
Keep it short and to the point. -29.22. In the year 2011, what is the difference between the Balance of Payment (as % of service exports) of Ireland and Balance of Payment (as % of service exports) of Sri Lanka?
Make the answer very short. -22.88. In the year 2011, what is the difference between the Balance of Payment (as % of service exports) of Lebanon and Balance of Payment (as % of service exports) of Sri Lanka?
Your answer should be very brief. 6.34. What is the ratio of the Balance of Payment (as % of service exports) of Sub-Saharan Africa (developing only) in 2005 to that in 2006?
Provide a short and direct response. 1.07. What is the ratio of the Balance of Payment (as % of service exports) of Ireland in 2005 to that in 2006?
Your response must be concise. 1.05. What is the ratio of the Balance of Payment (as % of service exports) of Lebanon in 2005 to that in 2006?
Offer a terse response. 1.19. What is the ratio of the Balance of Payment (as % of service exports) in Sri Lanka in 2005 to that in 2006?
Offer a very short reply. 1.1. What is the ratio of the Balance of Payment (as % of service exports) of Sub-Saharan Africa (developing only) in 2005 to that in 2007?
Give a very brief answer. 1.02. What is the ratio of the Balance of Payment (as % of service exports) in Ireland in 2005 to that in 2007?
Offer a terse response. 1.16. What is the ratio of the Balance of Payment (as % of service exports) of Lebanon in 2005 to that in 2007?
Give a very brief answer. 1.25. What is the ratio of the Balance of Payment (as % of service exports) in Sri Lanka in 2005 to that in 2007?
Keep it short and to the point. 1.28. What is the ratio of the Balance of Payment (as % of service exports) in Sub-Saharan Africa (developing only) in 2005 to that in 2008?
Your response must be concise. 1.1. What is the ratio of the Balance of Payment (as % of service exports) of Ireland in 2005 to that in 2008?
Keep it short and to the point. 1.22. What is the ratio of the Balance of Payment (as % of service exports) of Lebanon in 2005 to that in 2008?
Ensure brevity in your answer.  1.54. What is the ratio of the Balance of Payment (as % of service exports) in Sri Lanka in 2005 to that in 2008?
Keep it short and to the point. 1.63. What is the ratio of the Balance of Payment (as % of service exports) in Sub-Saharan Africa (developing only) in 2005 to that in 2009?
Provide a succinct answer. 1.08. What is the ratio of the Balance of Payment (as % of service exports) in Ireland in 2005 to that in 2009?
Give a very brief answer. 1.47. What is the ratio of the Balance of Payment (as % of service exports) of Lebanon in 2005 to that in 2009?
Ensure brevity in your answer.  1.27. What is the ratio of the Balance of Payment (as % of service exports) of Sri Lanka in 2005 to that in 2009?
Give a very brief answer. 1.51. What is the ratio of the Balance of Payment (as % of service exports) in Sub-Saharan Africa (developing only) in 2005 to that in 2010?
Give a very brief answer. 1.13. What is the ratio of the Balance of Payment (as % of service exports) in Ireland in 2005 to that in 2010?
Your response must be concise. 1.9. What is the ratio of the Balance of Payment (as % of service exports) in Lebanon in 2005 to that in 2010?
Provide a succinct answer. 1.04. What is the ratio of the Balance of Payment (as % of service exports) in Sri Lanka in 2005 to that in 2010?
Keep it short and to the point. 1.2. What is the ratio of the Balance of Payment (as % of service exports) of Sub-Saharan Africa (developing only) in 2005 to that in 2011?
Offer a very short reply. 1.17. What is the ratio of the Balance of Payment (as % of service exports) of Ireland in 2005 to that in 2011?
Your response must be concise. 2.15. What is the ratio of the Balance of Payment (as % of service exports) in Lebanon in 2005 to that in 2011?
Your answer should be very brief. 1.53. What is the ratio of the Balance of Payment (as % of service exports) of Sri Lanka in 2005 to that in 2011?
Your response must be concise. 1.03. What is the ratio of the Balance of Payment (as % of service exports) in Sub-Saharan Africa (developing only) in 2006 to that in 2007?
Your answer should be compact. 0.96. What is the ratio of the Balance of Payment (as % of service exports) in Ireland in 2006 to that in 2007?
Keep it short and to the point. 1.1. What is the ratio of the Balance of Payment (as % of service exports) in Lebanon in 2006 to that in 2007?
Your answer should be compact. 1.04. What is the ratio of the Balance of Payment (as % of service exports) of Sri Lanka in 2006 to that in 2007?
Give a very brief answer. 1.16. What is the ratio of the Balance of Payment (as % of service exports) of Sub-Saharan Africa (developing only) in 2006 to that in 2008?
Make the answer very short. 1.03. What is the ratio of the Balance of Payment (as % of service exports) of Ireland in 2006 to that in 2008?
Ensure brevity in your answer.  1.16. What is the ratio of the Balance of Payment (as % of service exports) in Lebanon in 2006 to that in 2008?
Offer a terse response. 1.29. What is the ratio of the Balance of Payment (as % of service exports) of Sri Lanka in 2006 to that in 2008?
Your response must be concise. 1.48. What is the ratio of the Balance of Payment (as % of service exports) in Sub-Saharan Africa (developing only) in 2006 to that in 2009?
Your answer should be very brief. 1.01. What is the ratio of the Balance of Payment (as % of service exports) in Ireland in 2006 to that in 2009?
Provide a succinct answer. 1.4. What is the ratio of the Balance of Payment (as % of service exports) in Lebanon in 2006 to that in 2009?
Provide a succinct answer. 1.07. What is the ratio of the Balance of Payment (as % of service exports) in Sri Lanka in 2006 to that in 2009?
Provide a succinct answer. 1.37. What is the ratio of the Balance of Payment (as % of service exports) of Sub-Saharan Africa (developing only) in 2006 to that in 2010?
Give a very brief answer. 1.05. What is the ratio of the Balance of Payment (as % of service exports) of Ireland in 2006 to that in 2010?
Offer a terse response. 1.8. What is the ratio of the Balance of Payment (as % of service exports) of Lebanon in 2006 to that in 2010?
Your response must be concise. 0.87. What is the ratio of the Balance of Payment (as % of service exports) of Sri Lanka in 2006 to that in 2010?
Make the answer very short. 1.08. What is the ratio of the Balance of Payment (as % of service exports) of Sub-Saharan Africa (developing only) in 2006 to that in 2011?
Your answer should be very brief. 1.09. What is the ratio of the Balance of Payment (as % of service exports) in Ireland in 2006 to that in 2011?
Provide a short and direct response. 2.04. What is the ratio of the Balance of Payment (as % of service exports) of Lebanon in 2006 to that in 2011?
Your response must be concise. 1.28. What is the ratio of the Balance of Payment (as % of service exports) of Sri Lanka in 2006 to that in 2011?
Keep it short and to the point. 0.94. What is the ratio of the Balance of Payment (as % of service exports) of Sub-Saharan Africa (developing only) in 2007 to that in 2008?
Offer a terse response. 1.08. What is the ratio of the Balance of Payment (as % of service exports) in Ireland in 2007 to that in 2008?
Offer a terse response. 1.05. What is the ratio of the Balance of Payment (as % of service exports) in Lebanon in 2007 to that in 2008?
Your answer should be compact. 1.24. What is the ratio of the Balance of Payment (as % of service exports) in Sri Lanka in 2007 to that in 2008?
Your answer should be very brief. 1.27. What is the ratio of the Balance of Payment (as % of service exports) in Sub-Saharan Africa (developing only) in 2007 to that in 2009?
Offer a very short reply. 1.05. What is the ratio of the Balance of Payment (as % of service exports) of Ireland in 2007 to that in 2009?
Give a very brief answer. 1.27. What is the ratio of the Balance of Payment (as % of service exports) of Lebanon in 2007 to that in 2009?
Offer a terse response. 1.02. What is the ratio of the Balance of Payment (as % of service exports) in Sri Lanka in 2007 to that in 2009?
Provide a short and direct response. 1.18. What is the ratio of the Balance of Payment (as % of service exports) in Sub-Saharan Africa (developing only) in 2007 to that in 2010?
Your answer should be very brief. 1.1. What is the ratio of the Balance of Payment (as % of service exports) in Ireland in 2007 to that in 2010?
Give a very brief answer. 1.63. What is the ratio of the Balance of Payment (as % of service exports) of Lebanon in 2007 to that in 2010?
Make the answer very short. 0.83. What is the ratio of the Balance of Payment (as % of service exports) in Sri Lanka in 2007 to that in 2010?
Keep it short and to the point. 0.93. What is the ratio of the Balance of Payment (as % of service exports) in Sub-Saharan Africa (developing only) in 2007 to that in 2011?
Provide a short and direct response. 1.14. What is the ratio of the Balance of Payment (as % of service exports) of Ireland in 2007 to that in 2011?
Give a very brief answer. 1.85. What is the ratio of the Balance of Payment (as % of service exports) in Lebanon in 2007 to that in 2011?
Provide a short and direct response. 1.23. What is the ratio of the Balance of Payment (as % of service exports) in Sri Lanka in 2007 to that in 2011?
Offer a terse response. 0.81. What is the ratio of the Balance of Payment (as % of service exports) of Ireland in 2008 to that in 2009?
Provide a short and direct response. 1.21. What is the ratio of the Balance of Payment (as % of service exports) in Lebanon in 2008 to that in 2009?
Keep it short and to the point. 0.82. What is the ratio of the Balance of Payment (as % of service exports) in Sri Lanka in 2008 to that in 2009?
Keep it short and to the point. 0.92. What is the ratio of the Balance of Payment (as % of service exports) of Sub-Saharan Africa (developing only) in 2008 to that in 2010?
Keep it short and to the point. 1.02. What is the ratio of the Balance of Payment (as % of service exports) of Ireland in 2008 to that in 2010?
Your answer should be very brief. 1.56. What is the ratio of the Balance of Payment (as % of service exports) of Lebanon in 2008 to that in 2010?
Offer a terse response. 0.67. What is the ratio of the Balance of Payment (as % of service exports) of Sri Lanka in 2008 to that in 2010?
Offer a very short reply. 0.73. What is the ratio of the Balance of Payment (as % of service exports) in Sub-Saharan Africa (developing only) in 2008 to that in 2011?
Provide a short and direct response. 1.06. What is the ratio of the Balance of Payment (as % of service exports) of Ireland in 2008 to that in 2011?
Provide a succinct answer. 1.76. What is the ratio of the Balance of Payment (as % of service exports) in Sri Lanka in 2008 to that in 2011?
Provide a short and direct response. 0.63. What is the ratio of the Balance of Payment (as % of service exports) of Sub-Saharan Africa (developing only) in 2009 to that in 2010?
Ensure brevity in your answer.  1.04. What is the ratio of the Balance of Payment (as % of service exports) of Ireland in 2009 to that in 2010?
Make the answer very short. 1.29. What is the ratio of the Balance of Payment (as % of service exports) of Lebanon in 2009 to that in 2010?
Make the answer very short. 0.82. What is the ratio of the Balance of Payment (as % of service exports) in Sri Lanka in 2009 to that in 2010?
Your answer should be compact. 0.79. What is the ratio of the Balance of Payment (as % of service exports) of Sub-Saharan Africa (developing only) in 2009 to that in 2011?
Offer a terse response. 1.08. What is the ratio of the Balance of Payment (as % of service exports) of Ireland in 2009 to that in 2011?
Offer a terse response. 1.46. What is the ratio of the Balance of Payment (as % of service exports) in Lebanon in 2009 to that in 2011?
Make the answer very short. 1.2. What is the ratio of the Balance of Payment (as % of service exports) in Sri Lanka in 2009 to that in 2011?
Your answer should be compact. 0.69. What is the ratio of the Balance of Payment (as % of service exports) of Sub-Saharan Africa (developing only) in 2010 to that in 2011?
Give a very brief answer. 1.04. What is the ratio of the Balance of Payment (as % of service exports) of Ireland in 2010 to that in 2011?
Keep it short and to the point. 1.13. What is the ratio of the Balance of Payment (as % of service exports) in Lebanon in 2010 to that in 2011?
Provide a succinct answer. 1.47. What is the ratio of the Balance of Payment (as % of service exports) in Sri Lanka in 2010 to that in 2011?
Your response must be concise. 0.86. What is the difference between the highest and the second highest Balance of Payment (as % of service exports) of Sub-Saharan Africa (developing only)?
Your response must be concise. 1.2. What is the difference between the highest and the second highest Balance of Payment (as % of service exports) of Ireland?
Your answer should be very brief. 0.45. What is the difference between the highest and the second highest Balance of Payment (as % of service exports) in Lebanon?
Offer a terse response. 1.91. What is the difference between the highest and the second highest Balance of Payment (as % of service exports) of Sri Lanka?
Offer a very short reply. 0.94. What is the difference between the highest and the lowest Balance of Payment (as % of service exports) in Sub-Saharan Africa (developing only)?
Keep it short and to the point. 7.14. What is the difference between the highest and the lowest Balance of Payment (as % of service exports) of Ireland?
Provide a short and direct response. 4.65. What is the difference between the highest and the lowest Balance of Payment (as % of service exports) in Lebanon?
Provide a succinct answer. 17.92. What is the difference between the highest and the lowest Balance of Payment (as % of service exports) in Sri Lanka?
Offer a very short reply. 10.78. 